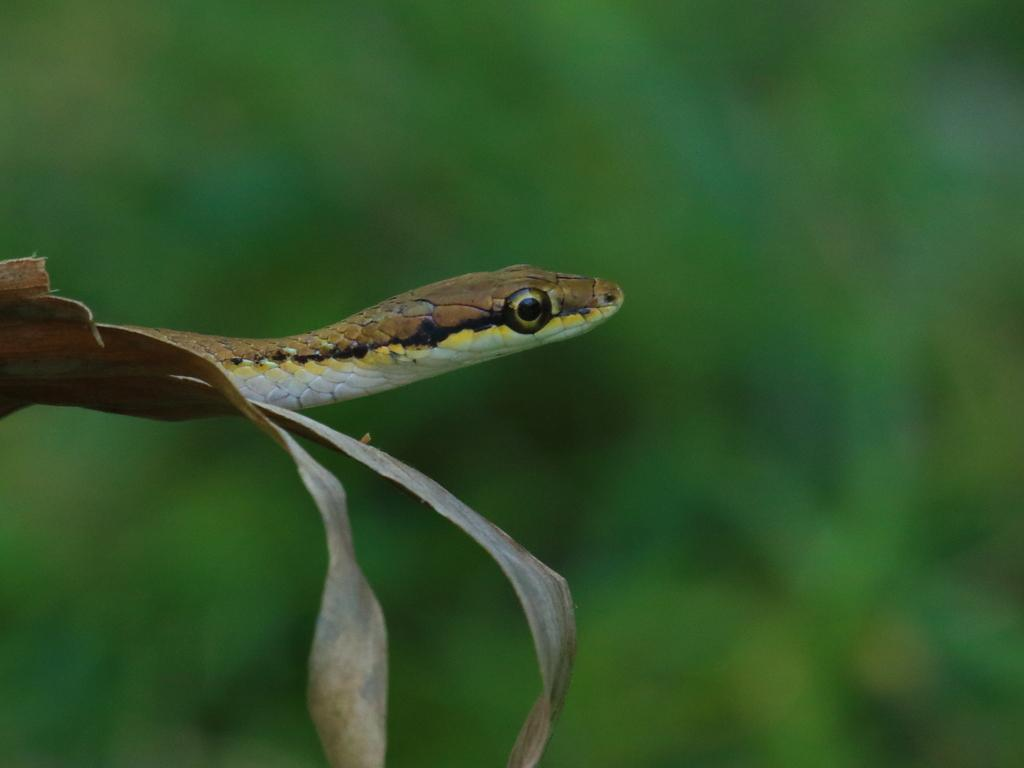What animal is present in the image? There is a snake in the image. Where is the snake located? The snake is on a plant. What color is the background of the image? The background of the image is green. How is the background of the image depicted? The background is blurred. Can you see the coat the snake is wearing in the image? There is no coat present in the image, as snakes do not wear clothing. 